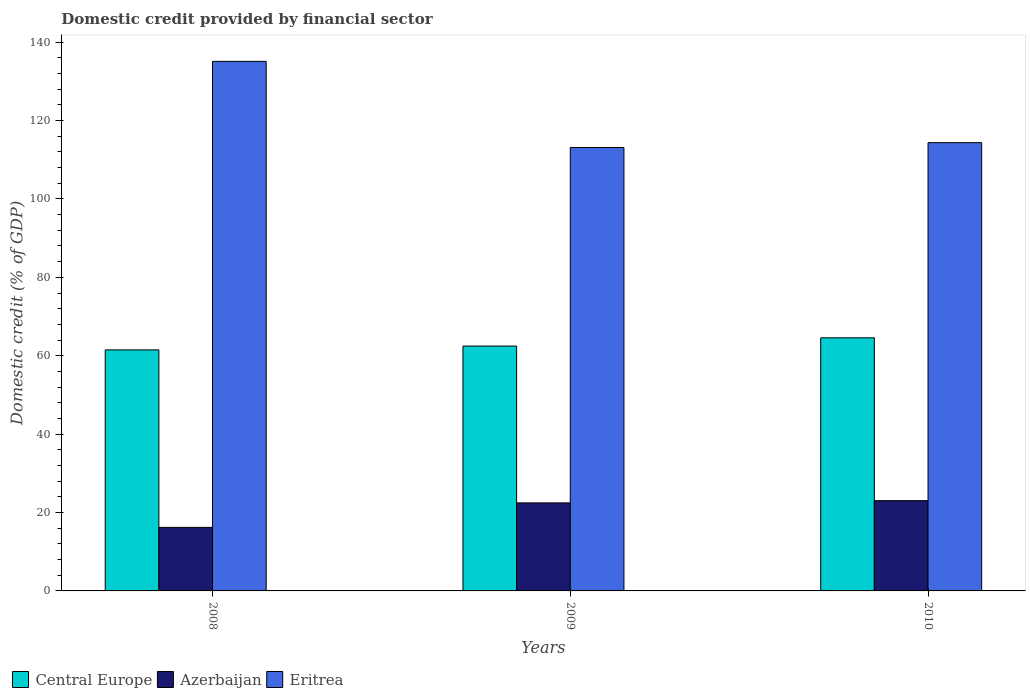How many different coloured bars are there?
Keep it short and to the point. 3. How many groups of bars are there?
Provide a succinct answer. 3. Are the number of bars on each tick of the X-axis equal?
Your answer should be very brief. Yes. How many bars are there on the 1st tick from the right?
Provide a succinct answer. 3. In how many cases, is the number of bars for a given year not equal to the number of legend labels?
Your answer should be very brief. 0. What is the domestic credit in Eritrea in 2008?
Keep it short and to the point. 135.1. Across all years, what is the maximum domestic credit in Azerbaijan?
Offer a terse response. 23.03. Across all years, what is the minimum domestic credit in Eritrea?
Give a very brief answer. 113.12. In which year was the domestic credit in Central Europe maximum?
Give a very brief answer. 2010. In which year was the domestic credit in Azerbaijan minimum?
Your answer should be compact. 2008. What is the total domestic credit in Central Europe in the graph?
Your response must be concise. 188.53. What is the difference between the domestic credit in Azerbaijan in 2009 and that in 2010?
Your answer should be very brief. -0.57. What is the difference between the domestic credit in Azerbaijan in 2010 and the domestic credit in Central Europe in 2009?
Your response must be concise. -39.44. What is the average domestic credit in Central Europe per year?
Give a very brief answer. 62.84. In the year 2009, what is the difference between the domestic credit in Azerbaijan and domestic credit in Central Europe?
Your answer should be very brief. -40.01. What is the ratio of the domestic credit in Central Europe in 2008 to that in 2009?
Provide a short and direct response. 0.98. Is the domestic credit in Azerbaijan in 2008 less than that in 2010?
Your answer should be very brief. Yes. What is the difference between the highest and the second highest domestic credit in Azerbaijan?
Give a very brief answer. 0.57. What is the difference between the highest and the lowest domestic credit in Eritrea?
Provide a short and direct response. 21.98. In how many years, is the domestic credit in Central Europe greater than the average domestic credit in Central Europe taken over all years?
Your response must be concise. 1. Is the sum of the domestic credit in Eritrea in 2008 and 2010 greater than the maximum domestic credit in Azerbaijan across all years?
Your answer should be very brief. Yes. What does the 1st bar from the left in 2008 represents?
Your answer should be very brief. Central Europe. What does the 1st bar from the right in 2010 represents?
Your response must be concise. Eritrea. How many bars are there?
Your answer should be compact. 9. Are all the bars in the graph horizontal?
Offer a very short reply. No. How many years are there in the graph?
Offer a terse response. 3. Are the values on the major ticks of Y-axis written in scientific E-notation?
Offer a very short reply. No. What is the title of the graph?
Make the answer very short. Domestic credit provided by financial sector. Does "Kenya" appear as one of the legend labels in the graph?
Provide a short and direct response. No. What is the label or title of the X-axis?
Your response must be concise. Years. What is the label or title of the Y-axis?
Keep it short and to the point. Domestic credit (% of GDP). What is the Domestic credit (% of GDP) of Central Europe in 2008?
Your answer should be compact. 61.49. What is the Domestic credit (% of GDP) of Azerbaijan in 2008?
Provide a short and direct response. 16.22. What is the Domestic credit (% of GDP) in Eritrea in 2008?
Keep it short and to the point. 135.1. What is the Domestic credit (% of GDP) of Central Europe in 2009?
Provide a short and direct response. 62.47. What is the Domestic credit (% of GDP) of Azerbaijan in 2009?
Provide a short and direct response. 22.46. What is the Domestic credit (% of GDP) of Eritrea in 2009?
Ensure brevity in your answer.  113.12. What is the Domestic credit (% of GDP) of Central Europe in 2010?
Your answer should be very brief. 64.57. What is the Domestic credit (% of GDP) of Azerbaijan in 2010?
Provide a succinct answer. 23.03. What is the Domestic credit (% of GDP) in Eritrea in 2010?
Offer a terse response. 114.36. Across all years, what is the maximum Domestic credit (% of GDP) of Central Europe?
Offer a very short reply. 64.57. Across all years, what is the maximum Domestic credit (% of GDP) in Azerbaijan?
Provide a short and direct response. 23.03. Across all years, what is the maximum Domestic credit (% of GDP) in Eritrea?
Offer a terse response. 135.1. Across all years, what is the minimum Domestic credit (% of GDP) of Central Europe?
Provide a short and direct response. 61.49. Across all years, what is the minimum Domestic credit (% of GDP) of Azerbaijan?
Provide a succinct answer. 16.22. Across all years, what is the minimum Domestic credit (% of GDP) in Eritrea?
Provide a short and direct response. 113.12. What is the total Domestic credit (% of GDP) of Central Europe in the graph?
Keep it short and to the point. 188.53. What is the total Domestic credit (% of GDP) of Azerbaijan in the graph?
Your response must be concise. 61.7. What is the total Domestic credit (% of GDP) in Eritrea in the graph?
Your answer should be compact. 362.59. What is the difference between the Domestic credit (% of GDP) of Central Europe in 2008 and that in 2009?
Ensure brevity in your answer.  -0.98. What is the difference between the Domestic credit (% of GDP) in Azerbaijan in 2008 and that in 2009?
Ensure brevity in your answer.  -6.24. What is the difference between the Domestic credit (% of GDP) in Eritrea in 2008 and that in 2009?
Offer a terse response. 21.98. What is the difference between the Domestic credit (% of GDP) of Central Europe in 2008 and that in 2010?
Offer a terse response. -3.08. What is the difference between the Domestic credit (% of GDP) in Azerbaijan in 2008 and that in 2010?
Keep it short and to the point. -6.81. What is the difference between the Domestic credit (% of GDP) of Eritrea in 2008 and that in 2010?
Keep it short and to the point. 20.74. What is the difference between the Domestic credit (% of GDP) in Central Europe in 2009 and that in 2010?
Provide a short and direct response. -2.1. What is the difference between the Domestic credit (% of GDP) of Azerbaijan in 2009 and that in 2010?
Your response must be concise. -0.57. What is the difference between the Domestic credit (% of GDP) in Eritrea in 2009 and that in 2010?
Provide a succinct answer. -1.24. What is the difference between the Domestic credit (% of GDP) of Central Europe in 2008 and the Domestic credit (% of GDP) of Azerbaijan in 2009?
Your answer should be very brief. 39.03. What is the difference between the Domestic credit (% of GDP) of Central Europe in 2008 and the Domestic credit (% of GDP) of Eritrea in 2009?
Offer a very short reply. -51.64. What is the difference between the Domestic credit (% of GDP) of Azerbaijan in 2008 and the Domestic credit (% of GDP) of Eritrea in 2009?
Provide a succinct answer. -96.91. What is the difference between the Domestic credit (% of GDP) in Central Europe in 2008 and the Domestic credit (% of GDP) in Azerbaijan in 2010?
Your answer should be very brief. 38.46. What is the difference between the Domestic credit (% of GDP) in Central Europe in 2008 and the Domestic credit (% of GDP) in Eritrea in 2010?
Your answer should be very brief. -52.87. What is the difference between the Domestic credit (% of GDP) in Azerbaijan in 2008 and the Domestic credit (% of GDP) in Eritrea in 2010?
Provide a short and direct response. -98.15. What is the difference between the Domestic credit (% of GDP) in Central Europe in 2009 and the Domestic credit (% of GDP) in Azerbaijan in 2010?
Your answer should be compact. 39.44. What is the difference between the Domestic credit (% of GDP) of Central Europe in 2009 and the Domestic credit (% of GDP) of Eritrea in 2010?
Offer a very short reply. -51.89. What is the difference between the Domestic credit (% of GDP) of Azerbaijan in 2009 and the Domestic credit (% of GDP) of Eritrea in 2010?
Keep it short and to the point. -91.9. What is the average Domestic credit (% of GDP) in Central Europe per year?
Your answer should be very brief. 62.84. What is the average Domestic credit (% of GDP) in Azerbaijan per year?
Ensure brevity in your answer.  20.57. What is the average Domestic credit (% of GDP) in Eritrea per year?
Your answer should be compact. 120.86. In the year 2008, what is the difference between the Domestic credit (% of GDP) of Central Europe and Domestic credit (% of GDP) of Azerbaijan?
Provide a short and direct response. 45.27. In the year 2008, what is the difference between the Domestic credit (% of GDP) in Central Europe and Domestic credit (% of GDP) in Eritrea?
Make the answer very short. -73.61. In the year 2008, what is the difference between the Domestic credit (% of GDP) of Azerbaijan and Domestic credit (% of GDP) of Eritrea?
Ensure brevity in your answer.  -118.88. In the year 2009, what is the difference between the Domestic credit (% of GDP) in Central Europe and Domestic credit (% of GDP) in Azerbaijan?
Your answer should be compact. 40.01. In the year 2009, what is the difference between the Domestic credit (% of GDP) of Central Europe and Domestic credit (% of GDP) of Eritrea?
Offer a very short reply. -50.66. In the year 2009, what is the difference between the Domestic credit (% of GDP) of Azerbaijan and Domestic credit (% of GDP) of Eritrea?
Your answer should be very brief. -90.67. In the year 2010, what is the difference between the Domestic credit (% of GDP) of Central Europe and Domestic credit (% of GDP) of Azerbaijan?
Your answer should be compact. 41.54. In the year 2010, what is the difference between the Domestic credit (% of GDP) in Central Europe and Domestic credit (% of GDP) in Eritrea?
Provide a short and direct response. -49.79. In the year 2010, what is the difference between the Domestic credit (% of GDP) in Azerbaijan and Domestic credit (% of GDP) in Eritrea?
Give a very brief answer. -91.33. What is the ratio of the Domestic credit (% of GDP) of Central Europe in 2008 to that in 2009?
Offer a terse response. 0.98. What is the ratio of the Domestic credit (% of GDP) in Azerbaijan in 2008 to that in 2009?
Offer a very short reply. 0.72. What is the ratio of the Domestic credit (% of GDP) of Eritrea in 2008 to that in 2009?
Your response must be concise. 1.19. What is the ratio of the Domestic credit (% of GDP) of Central Europe in 2008 to that in 2010?
Offer a very short reply. 0.95. What is the ratio of the Domestic credit (% of GDP) of Azerbaijan in 2008 to that in 2010?
Offer a very short reply. 0.7. What is the ratio of the Domestic credit (% of GDP) in Eritrea in 2008 to that in 2010?
Offer a terse response. 1.18. What is the ratio of the Domestic credit (% of GDP) of Central Europe in 2009 to that in 2010?
Offer a very short reply. 0.97. What is the ratio of the Domestic credit (% of GDP) in Azerbaijan in 2009 to that in 2010?
Ensure brevity in your answer.  0.98. What is the ratio of the Domestic credit (% of GDP) in Eritrea in 2009 to that in 2010?
Provide a succinct answer. 0.99. What is the difference between the highest and the second highest Domestic credit (% of GDP) in Central Europe?
Offer a terse response. 2.1. What is the difference between the highest and the second highest Domestic credit (% of GDP) of Azerbaijan?
Offer a terse response. 0.57. What is the difference between the highest and the second highest Domestic credit (% of GDP) in Eritrea?
Offer a very short reply. 20.74. What is the difference between the highest and the lowest Domestic credit (% of GDP) of Central Europe?
Make the answer very short. 3.08. What is the difference between the highest and the lowest Domestic credit (% of GDP) of Azerbaijan?
Your response must be concise. 6.81. What is the difference between the highest and the lowest Domestic credit (% of GDP) of Eritrea?
Your response must be concise. 21.98. 